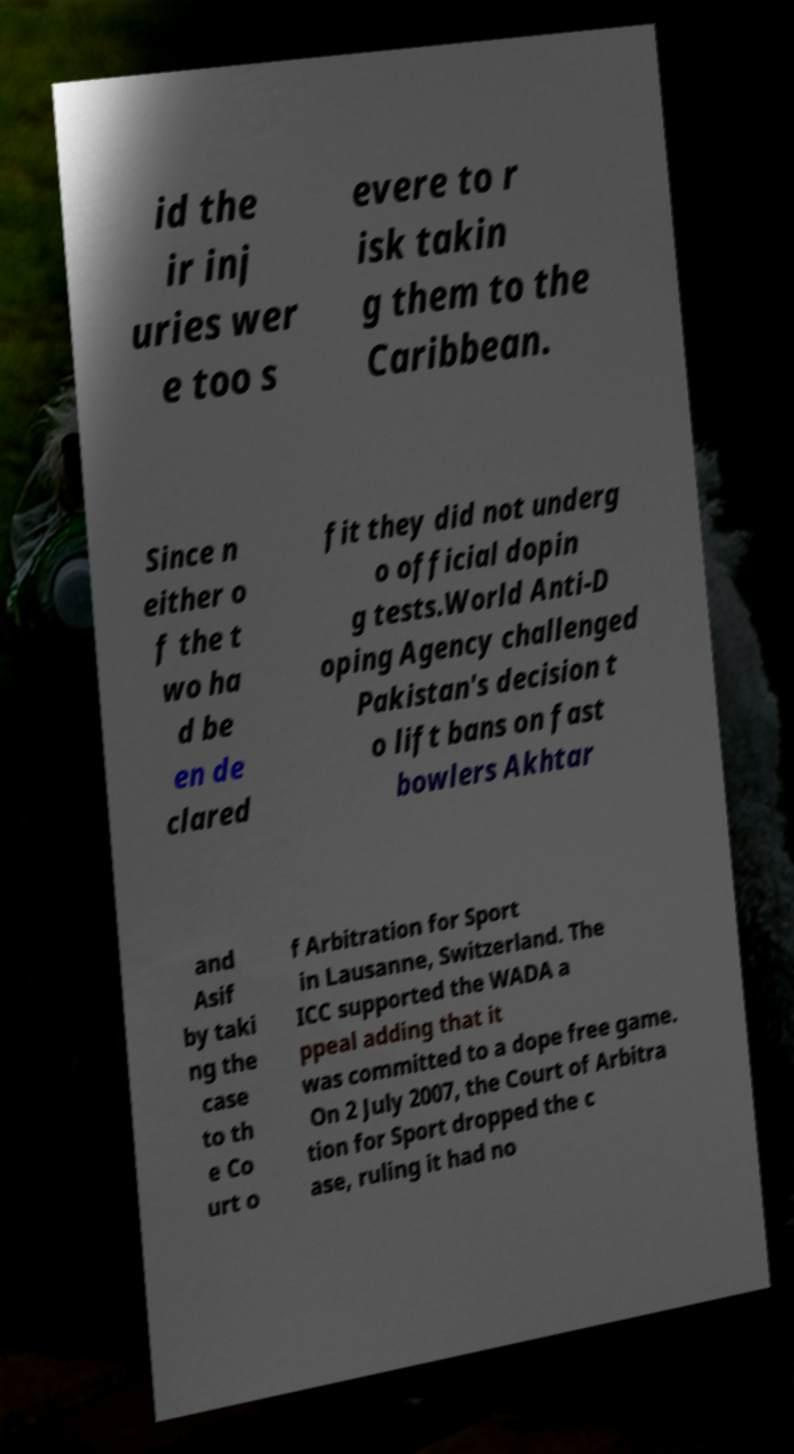Could you extract and type out the text from this image? id the ir inj uries wer e too s evere to r isk takin g them to the Caribbean. Since n either o f the t wo ha d be en de clared fit they did not underg o official dopin g tests.World Anti-D oping Agency challenged Pakistan's decision t o lift bans on fast bowlers Akhtar and Asif by taki ng the case to th e Co urt o f Arbitration for Sport in Lausanne, Switzerland. The ICC supported the WADA a ppeal adding that it was committed to a dope free game. On 2 July 2007, the Court of Arbitra tion for Sport dropped the c ase, ruling it had no 